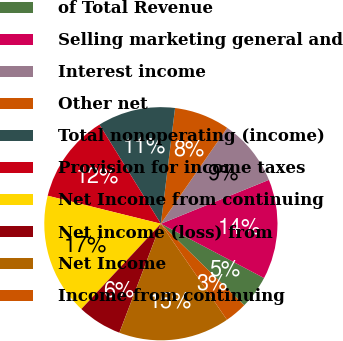Convert chart. <chart><loc_0><loc_0><loc_500><loc_500><pie_chart><fcel>of Total Revenue<fcel>Selling marketing general and<fcel>Interest income<fcel>Other net<fcel>Total nonoperating (income)<fcel>Provision for income taxes<fcel>Net Income from continuing<fcel>Net income (loss) from<fcel>Net Income<fcel>Income from continuing<nl><fcel>4.62%<fcel>13.85%<fcel>9.23%<fcel>7.69%<fcel>10.77%<fcel>12.31%<fcel>16.92%<fcel>6.15%<fcel>15.38%<fcel>3.08%<nl></chart> 